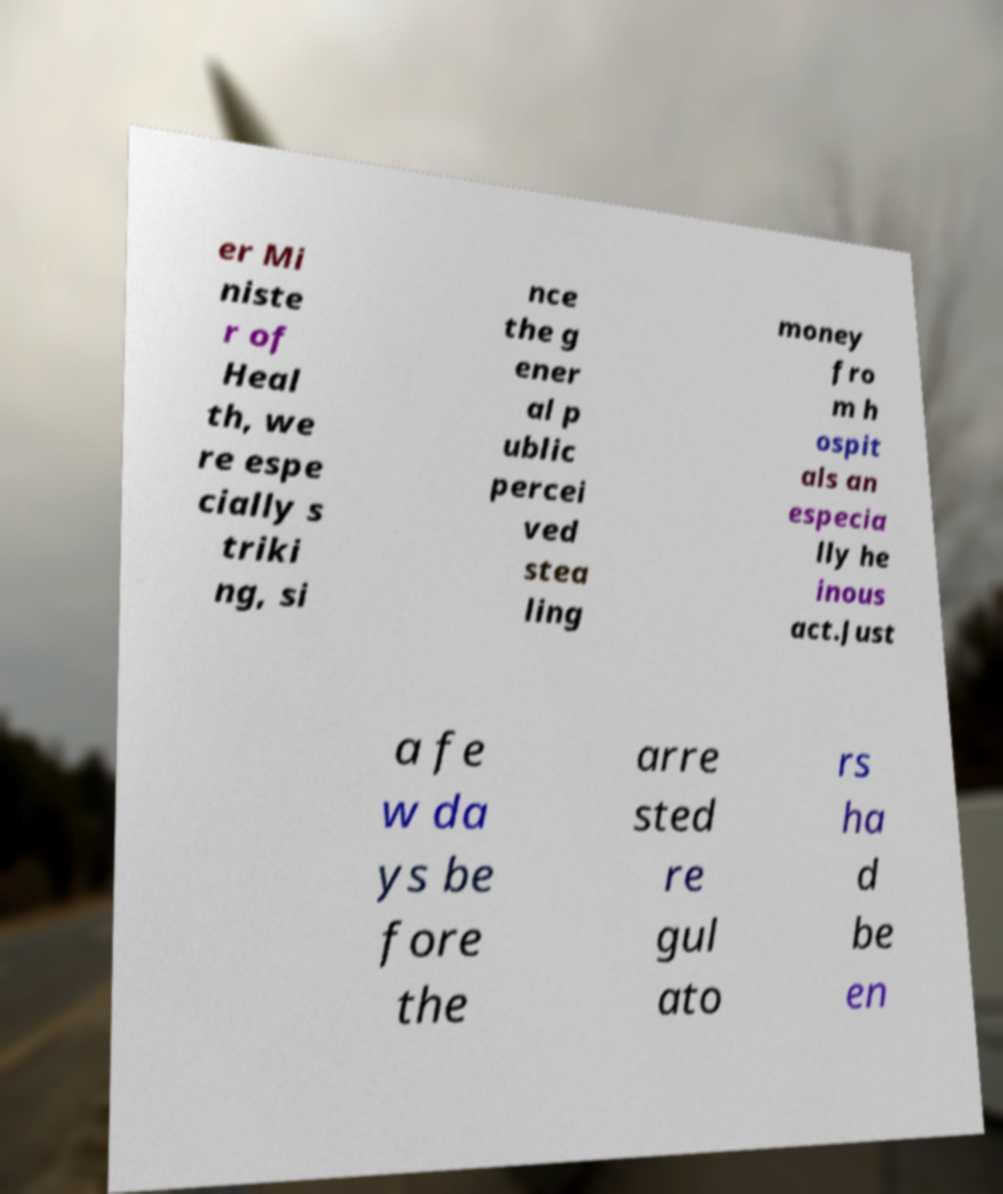Please identify and transcribe the text found in this image. er Mi niste r of Heal th, we re espe cially s triki ng, si nce the g ener al p ublic percei ved stea ling money fro m h ospit als an especia lly he inous act.Just a fe w da ys be fore the arre sted re gul ato rs ha d be en 